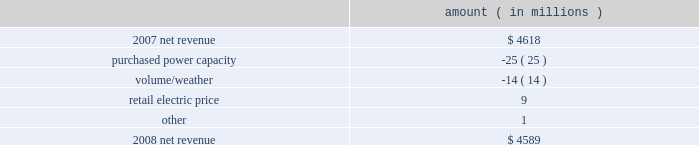Entergy corporation and subsidiaries management's financial discussion and analysis the expenses related to the voluntary severance program offered to employees .
Approximately 200 employees from the non-utility nuclear business and 150 employees in the utility business accepted the voluntary severance program offers .
Net revenue utility following is an analysis of the change in net revenue comparing 2008 to 2007 .
Amount ( in millions ) .
The purchased power capacity variance is primarily due to higher capacity charges .
A portion of the variance is due to the amortization of deferred capacity costs and is offset in base revenues due to base rate increases implemented to recover incremental deferred and ongoing purchased power capacity charges .
The volume/weather variance is primarily due to the effect of less favorable weather compared to the same period in 2007 and decreased electricity usage primarily during the unbilled sales period .
Hurricane gustav and hurricane ike , which hit the utility's service territories in september 2008 , contributed an estimated $ 46 million to the decrease in electricity usage .
Industrial sales were also depressed by the continuing effects of the hurricanes and , especially in the latter part of the year , because of the overall decline of the economy , leading to lower usage in the latter part of the year affecting both the large customer industrial segment as well as small and mid-sized industrial customers .
The decreases in electricity usage were partially offset by an increase in residential and commercial customer electricity usage that occurred during the periods of the year not affected by the hurricanes .
The retail electric price variance is primarily due to : an increase in the attala power plant costs recovered through the power management rider by entergy mississippi .
The net income effect of this recovery is limited to a portion representing an allowed return on equity with the remainder offset by attala power plant costs in other operation and maintenance expenses , depreciation expenses , and taxes other than income taxes ; a storm damage rider that became effective in october 2007 at entergy mississippi ; and an energy efficiency rider that became effective in november 2007 at entergy arkansas .
The establishment of the storm damage rider and the energy efficiency rider results in an increase in rider revenue and a corresponding increase in other operation and maintenance expense with no impact on net income .
The retail electric price variance was partially offset by : the absence of interim storm recoveries through the formula rate plans at entergy louisiana and entergy gulf states louisiana which ceased upon the act 55 financing of storm costs in the third quarter 2008 ; and a credit passed on to customers as a result of the act 55 storm cost financings .
Refer to "liquidity and capital resources - hurricane katrina and hurricane rita" below and note 2 to the financial statements for a discussion of the interim recovery of storm costs and the act 55 storm cost financings. .
What percent lower was the revenue in 2008 than in 2007? 
Computations: (4618 - 4589)
Answer: 29.0. 